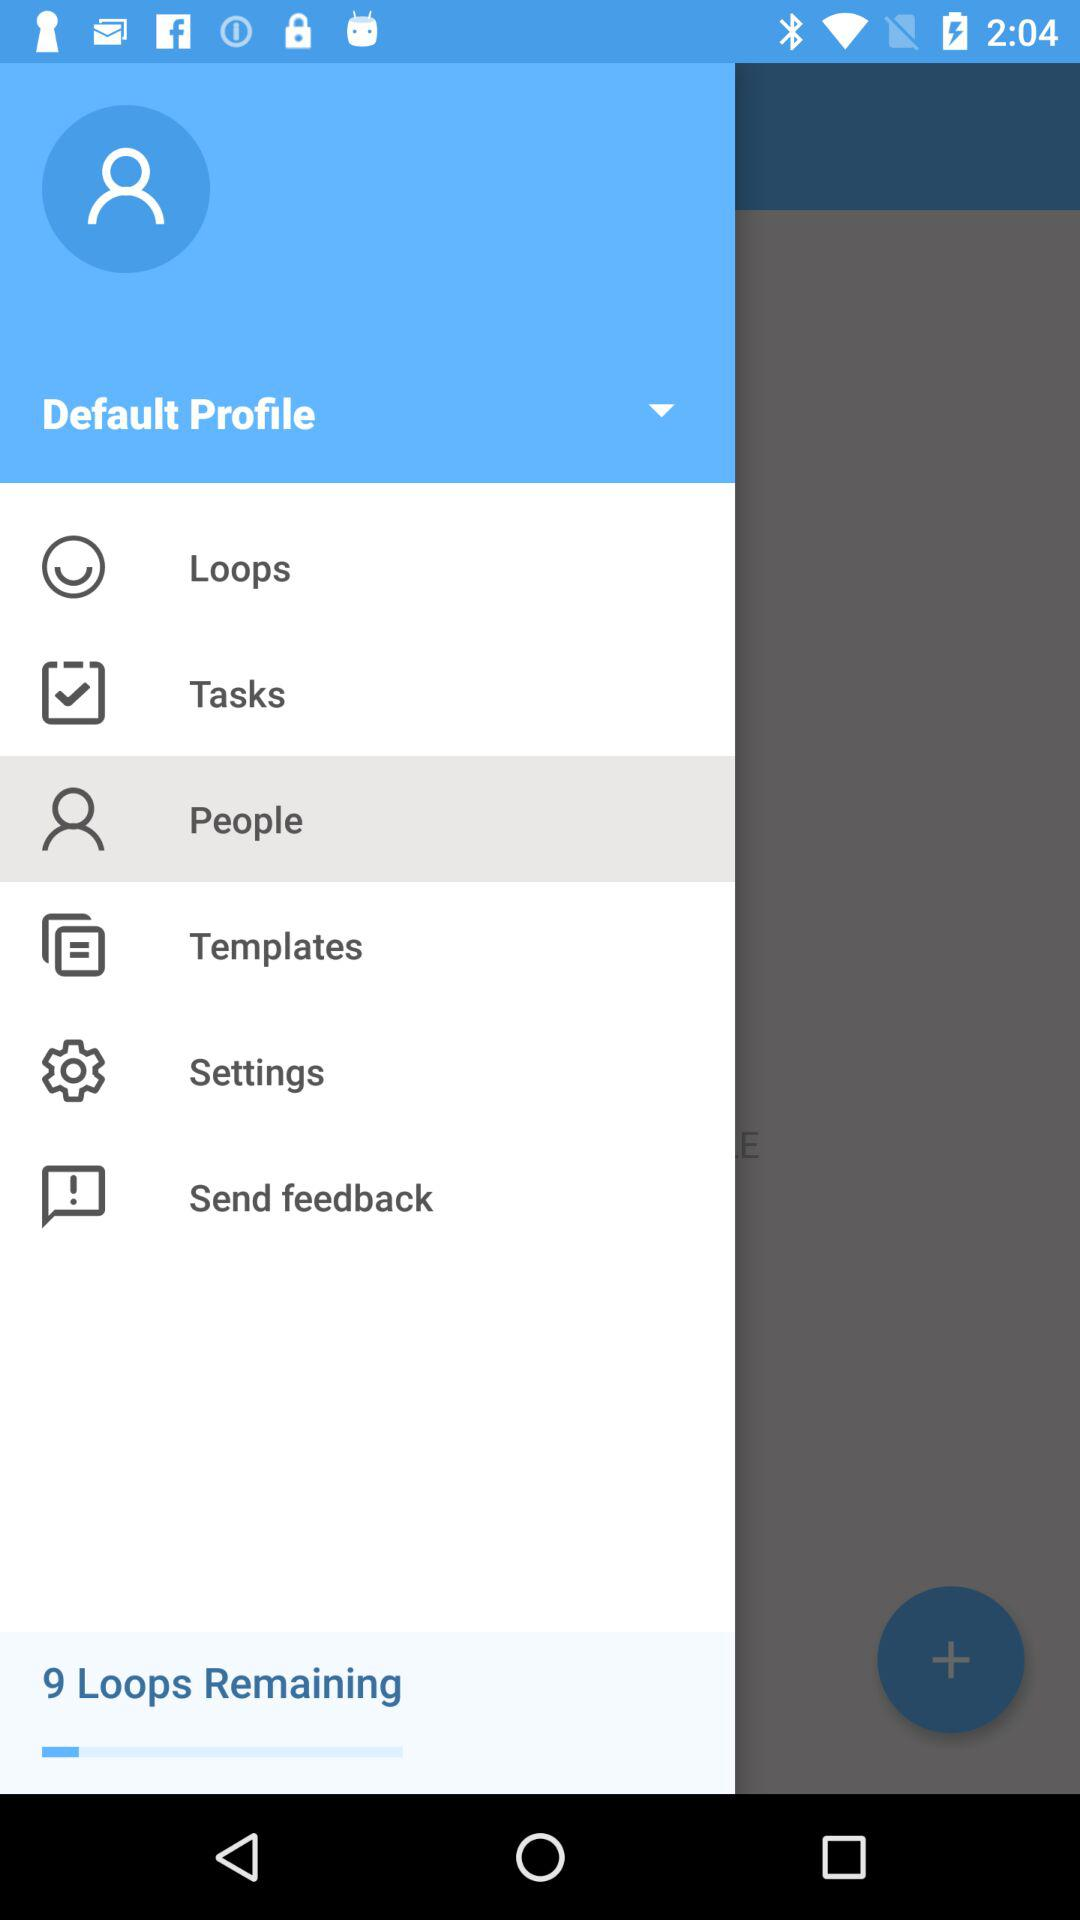How many loops are remaining? There are 9 loops remaining. 